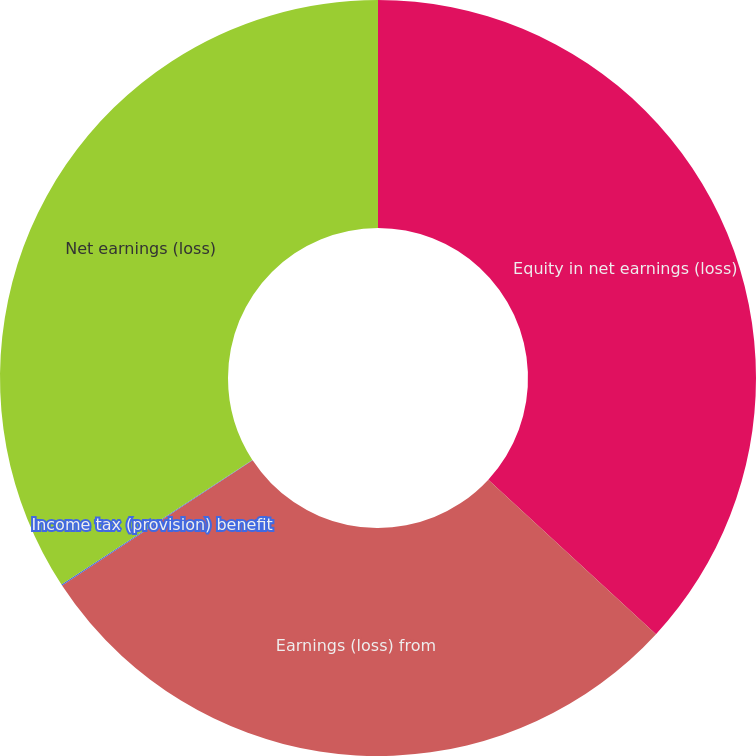<chart> <loc_0><loc_0><loc_500><loc_500><pie_chart><fcel>Equity in net earnings (loss)<fcel>Earnings (loss) from<fcel>Income tax (provision) benefit<fcel>Net earnings (loss)<nl><fcel>36.85%<fcel>28.9%<fcel>0.05%<fcel>34.2%<nl></chart> 